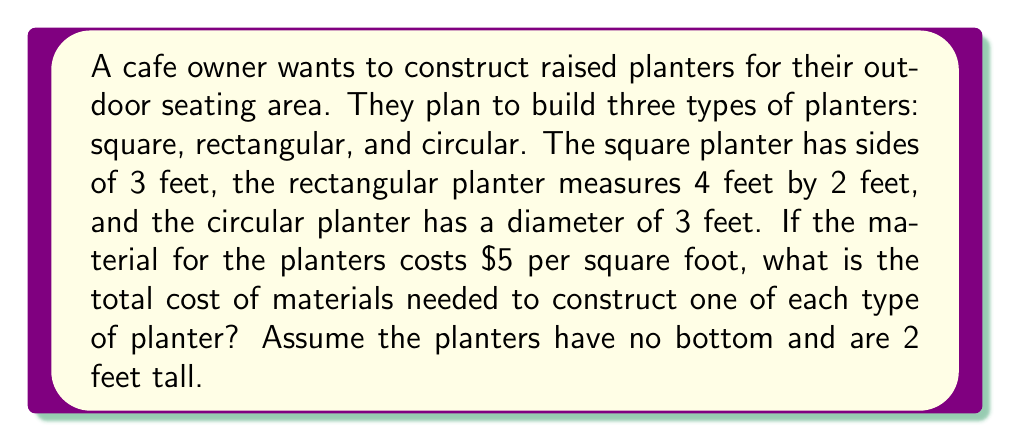Give your solution to this math problem. Let's calculate the cost for each planter separately:

1. Square planter:
   - Perimeter: $4 \times 3 = 12$ feet
   - Area to cover: $12 \times 2 = 24$ sq ft
   - Cost: $24 \times $5 = $120$

2. Rectangular planter:
   - Perimeter: $2(4 + 2) = 12$ feet
   - Area to cover: $12 \times 2 = 24$ sq ft
   - Cost: $24 \times $5 = $120$

3. Circular planter:
   - Circumference: $\pi d = \pi \times 3 \approx 9.42$ feet
   - Area to cover: $9.42 \times 2 \approx 18.85$ sq ft
   - Cost: $18.85 \times $5 \approx $94.25$

Total cost:
$$120 + 120 + 94.25 = $334.25$$

Rounding to the nearest dollar: $334
Answer: $334 